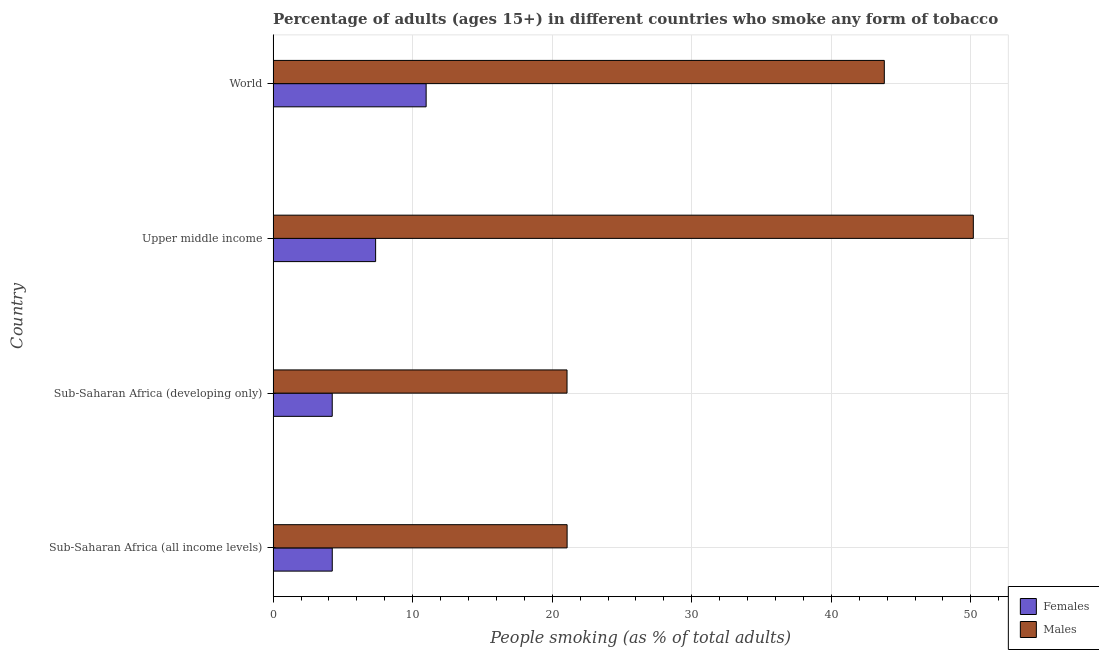How many groups of bars are there?
Provide a succinct answer. 4. How many bars are there on the 3rd tick from the top?
Your response must be concise. 2. How many bars are there on the 4th tick from the bottom?
Offer a very short reply. 2. What is the percentage of males who smoke in World?
Provide a succinct answer. 43.8. Across all countries, what is the maximum percentage of males who smoke?
Your answer should be very brief. 50.18. Across all countries, what is the minimum percentage of males who smoke?
Ensure brevity in your answer.  21.06. In which country was the percentage of females who smoke maximum?
Make the answer very short. World. In which country was the percentage of males who smoke minimum?
Your answer should be very brief. Sub-Saharan Africa (developing only). What is the total percentage of males who smoke in the graph?
Your answer should be very brief. 136.1. What is the difference between the percentage of males who smoke in Upper middle income and that in World?
Keep it short and to the point. 6.38. What is the difference between the percentage of males who smoke in Sub-Saharan Africa (all income levels) and the percentage of females who smoke in Upper middle income?
Provide a succinct answer. 13.72. What is the average percentage of females who smoke per country?
Make the answer very short. 6.7. What is the difference between the percentage of males who smoke and percentage of females who smoke in World?
Give a very brief answer. 32.83. In how many countries, is the percentage of males who smoke greater than 32 %?
Give a very brief answer. 2. What is the ratio of the percentage of males who smoke in Upper middle income to that in World?
Your response must be concise. 1.15. Is the difference between the percentage of females who smoke in Sub-Saharan Africa (all income levels) and World greater than the difference between the percentage of males who smoke in Sub-Saharan Africa (all income levels) and World?
Give a very brief answer. Yes. What is the difference between the highest and the second highest percentage of males who smoke?
Provide a succinct answer. 6.38. What is the difference between the highest and the lowest percentage of males who smoke?
Ensure brevity in your answer.  29.11. In how many countries, is the percentage of males who smoke greater than the average percentage of males who smoke taken over all countries?
Provide a short and direct response. 2. Is the sum of the percentage of females who smoke in Sub-Saharan Africa (developing only) and Upper middle income greater than the maximum percentage of males who smoke across all countries?
Keep it short and to the point. No. What does the 1st bar from the top in Upper middle income represents?
Give a very brief answer. Males. What does the 1st bar from the bottom in World represents?
Make the answer very short. Females. Are the values on the major ticks of X-axis written in scientific E-notation?
Provide a succinct answer. No. Does the graph contain any zero values?
Your answer should be compact. No. Does the graph contain grids?
Give a very brief answer. Yes. How are the legend labels stacked?
Offer a very short reply. Vertical. What is the title of the graph?
Give a very brief answer. Percentage of adults (ages 15+) in different countries who smoke any form of tobacco. What is the label or title of the X-axis?
Offer a very short reply. People smoking (as % of total adults). What is the People smoking (as % of total adults) of Females in Sub-Saharan Africa (all income levels)?
Give a very brief answer. 4.24. What is the People smoking (as % of total adults) of Males in Sub-Saharan Africa (all income levels)?
Your response must be concise. 21.07. What is the People smoking (as % of total adults) in Females in Sub-Saharan Africa (developing only)?
Keep it short and to the point. 4.24. What is the People smoking (as % of total adults) of Males in Sub-Saharan Africa (developing only)?
Your response must be concise. 21.06. What is the People smoking (as % of total adults) of Females in Upper middle income?
Offer a terse response. 7.35. What is the People smoking (as % of total adults) in Males in Upper middle income?
Keep it short and to the point. 50.18. What is the People smoking (as % of total adults) in Females in World?
Offer a very short reply. 10.97. What is the People smoking (as % of total adults) of Males in World?
Your response must be concise. 43.8. Across all countries, what is the maximum People smoking (as % of total adults) in Females?
Give a very brief answer. 10.97. Across all countries, what is the maximum People smoking (as % of total adults) in Males?
Offer a very short reply. 50.18. Across all countries, what is the minimum People smoking (as % of total adults) of Females?
Ensure brevity in your answer.  4.24. Across all countries, what is the minimum People smoking (as % of total adults) in Males?
Give a very brief answer. 21.06. What is the total People smoking (as % of total adults) of Females in the graph?
Your response must be concise. 26.78. What is the total People smoking (as % of total adults) of Males in the graph?
Offer a terse response. 136.1. What is the difference between the People smoking (as % of total adults) of Females in Sub-Saharan Africa (all income levels) and that in Sub-Saharan Africa (developing only)?
Offer a very short reply. 0. What is the difference between the People smoking (as % of total adults) of Males in Sub-Saharan Africa (all income levels) and that in Sub-Saharan Africa (developing only)?
Provide a succinct answer. 0.01. What is the difference between the People smoking (as % of total adults) of Females in Sub-Saharan Africa (all income levels) and that in Upper middle income?
Keep it short and to the point. -3.11. What is the difference between the People smoking (as % of total adults) in Males in Sub-Saharan Africa (all income levels) and that in Upper middle income?
Ensure brevity in your answer.  -29.11. What is the difference between the People smoking (as % of total adults) of Females in Sub-Saharan Africa (all income levels) and that in World?
Make the answer very short. -6.73. What is the difference between the People smoking (as % of total adults) of Males in Sub-Saharan Africa (all income levels) and that in World?
Offer a terse response. -22.73. What is the difference between the People smoking (as % of total adults) of Females in Sub-Saharan Africa (developing only) and that in Upper middle income?
Your answer should be compact. -3.11. What is the difference between the People smoking (as % of total adults) of Males in Sub-Saharan Africa (developing only) and that in Upper middle income?
Provide a succinct answer. -29.11. What is the difference between the People smoking (as % of total adults) of Females in Sub-Saharan Africa (developing only) and that in World?
Ensure brevity in your answer.  -6.73. What is the difference between the People smoking (as % of total adults) of Males in Sub-Saharan Africa (developing only) and that in World?
Provide a short and direct response. -22.74. What is the difference between the People smoking (as % of total adults) in Females in Upper middle income and that in World?
Offer a very short reply. -3.62. What is the difference between the People smoking (as % of total adults) in Males in Upper middle income and that in World?
Give a very brief answer. 6.38. What is the difference between the People smoking (as % of total adults) in Females in Sub-Saharan Africa (all income levels) and the People smoking (as % of total adults) in Males in Sub-Saharan Africa (developing only)?
Your response must be concise. -16.82. What is the difference between the People smoking (as % of total adults) of Females in Sub-Saharan Africa (all income levels) and the People smoking (as % of total adults) of Males in Upper middle income?
Provide a succinct answer. -45.94. What is the difference between the People smoking (as % of total adults) of Females in Sub-Saharan Africa (all income levels) and the People smoking (as % of total adults) of Males in World?
Offer a terse response. -39.56. What is the difference between the People smoking (as % of total adults) of Females in Sub-Saharan Africa (developing only) and the People smoking (as % of total adults) of Males in Upper middle income?
Ensure brevity in your answer.  -45.94. What is the difference between the People smoking (as % of total adults) in Females in Sub-Saharan Africa (developing only) and the People smoking (as % of total adults) in Males in World?
Your answer should be compact. -39.56. What is the difference between the People smoking (as % of total adults) in Females in Upper middle income and the People smoking (as % of total adults) in Males in World?
Keep it short and to the point. -36.45. What is the average People smoking (as % of total adults) of Females per country?
Your answer should be very brief. 6.7. What is the average People smoking (as % of total adults) of Males per country?
Ensure brevity in your answer.  34.02. What is the difference between the People smoking (as % of total adults) of Females and People smoking (as % of total adults) of Males in Sub-Saharan Africa (all income levels)?
Provide a succinct answer. -16.83. What is the difference between the People smoking (as % of total adults) of Females and People smoking (as % of total adults) of Males in Sub-Saharan Africa (developing only)?
Give a very brief answer. -16.82. What is the difference between the People smoking (as % of total adults) of Females and People smoking (as % of total adults) of Males in Upper middle income?
Keep it short and to the point. -42.83. What is the difference between the People smoking (as % of total adults) of Females and People smoking (as % of total adults) of Males in World?
Your answer should be very brief. -32.83. What is the ratio of the People smoking (as % of total adults) in Females in Sub-Saharan Africa (all income levels) to that in Sub-Saharan Africa (developing only)?
Give a very brief answer. 1. What is the ratio of the People smoking (as % of total adults) in Males in Sub-Saharan Africa (all income levels) to that in Sub-Saharan Africa (developing only)?
Your answer should be compact. 1. What is the ratio of the People smoking (as % of total adults) of Females in Sub-Saharan Africa (all income levels) to that in Upper middle income?
Offer a very short reply. 0.58. What is the ratio of the People smoking (as % of total adults) of Males in Sub-Saharan Africa (all income levels) to that in Upper middle income?
Offer a very short reply. 0.42. What is the ratio of the People smoking (as % of total adults) of Females in Sub-Saharan Africa (all income levels) to that in World?
Provide a succinct answer. 0.39. What is the ratio of the People smoking (as % of total adults) in Males in Sub-Saharan Africa (all income levels) to that in World?
Give a very brief answer. 0.48. What is the ratio of the People smoking (as % of total adults) of Females in Sub-Saharan Africa (developing only) to that in Upper middle income?
Offer a very short reply. 0.58. What is the ratio of the People smoking (as % of total adults) in Males in Sub-Saharan Africa (developing only) to that in Upper middle income?
Make the answer very short. 0.42. What is the ratio of the People smoking (as % of total adults) in Females in Sub-Saharan Africa (developing only) to that in World?
Make the answer very short. 0.39. What is the ratio of the People smoking (as % of total adults) of Males in Sub-Saharan Africa (developing only) to that in World?
Give a very brief answer. 0.48. What is the ratio of the People smoking (as % of total adults) in Females in Upper middle income to that in World?
Provide a succinct answer. 0.67. What is the ratio of the People smoking (as % of total adults) of Males in Upper middle income to that in World?
Make the answer very short. 1.15. What is the difference between the highest and the second highest People smoking (as % of total adults) in Females?
Offer a very short reply. 3.62. What is the difference between the highest and the second highest People smoking (as % of total adults) of Males?
Your answer should be very brief. 6.38. What is the difference between the highest and the lowest People smoking (as % of total adults) in Females?
Your answer should be very brief. 6.73. What is the difference between the highest and the lowest People smoking (as % of total adults) in Males?
Make the answer very short. 29.11. 